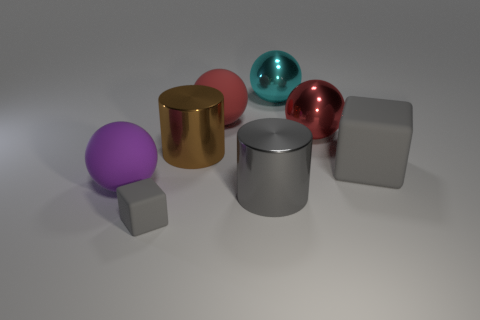Add 1 shiny balls. How many objects exist? 9 Subtract all blocks. How many objects are left? 6 Add 1 small matte blocks. How many small matte blocks exist? 2 Subtract 0 brown blocks. How many objects are left? 8 Subtract all brown metallic cylinders. Subtract all red rubber things. How many objects are left? 6 Add 2 big brown metallic objects. How many big brown metallic objects are left? 3 